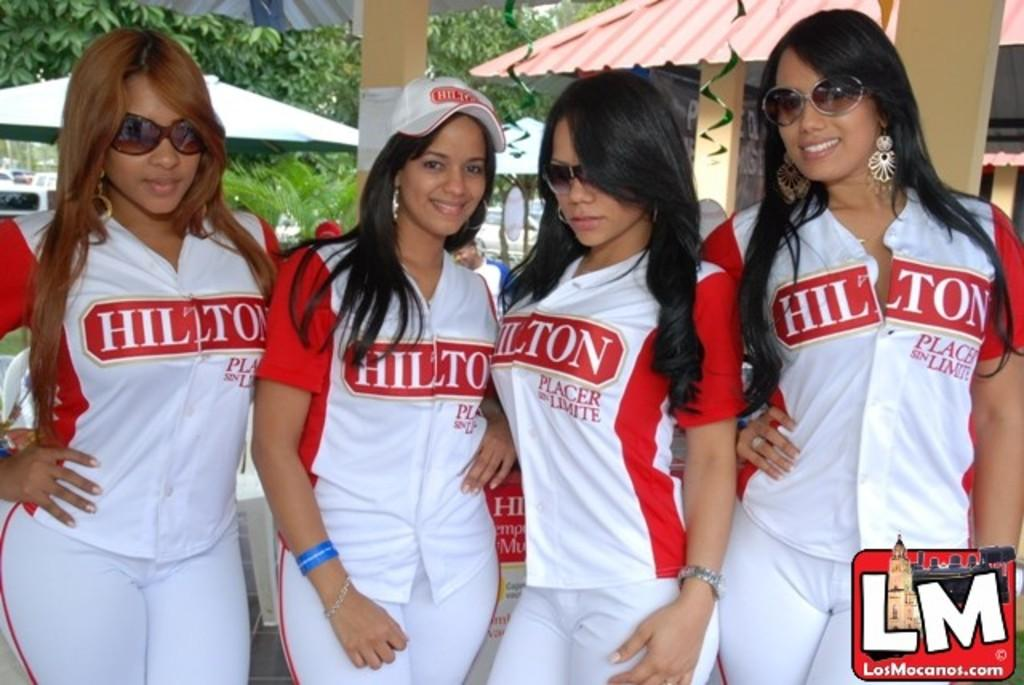<image>
Relay a brief, clear account of the picture shown. Four young women are dressed in red and white Hilton outfits. 